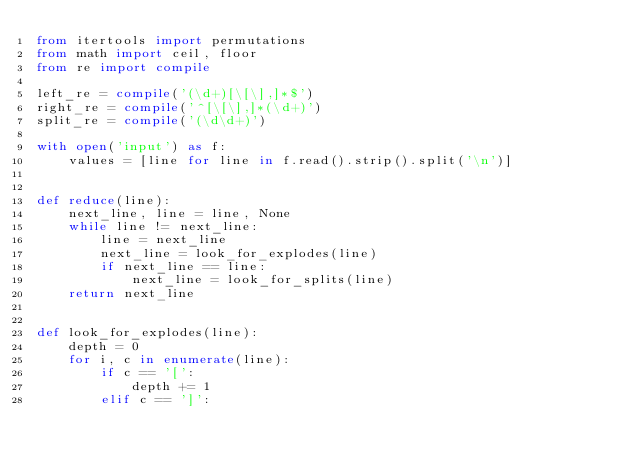<code> <loc_0><loc_0><loc_500><loc_500><_Python_>from itertools import permutations
from math import ceil, floor
from re import compile

left_re = compile('(\d+)[\[\],]*$')
right_re = compile('^[\[\],]*(\d+)')
split_re = compile('(\d\d+)')

with open('input') as f:
    values = [line for line in f.read().strip().split('\n')]


def reduce(line):
    next_line, line = line, None
    while line != next_line:
        line = next_line
        next_line = look_for_explodes(line)
        if next_line == line:
            next_line = look_for_splits(line)
    return next_line


def look_for_explodes(line):
    depth = 0
    for i, c in enumerate(line):
        if c == '[':
            depth += 1
        elif c == ']':</code> 